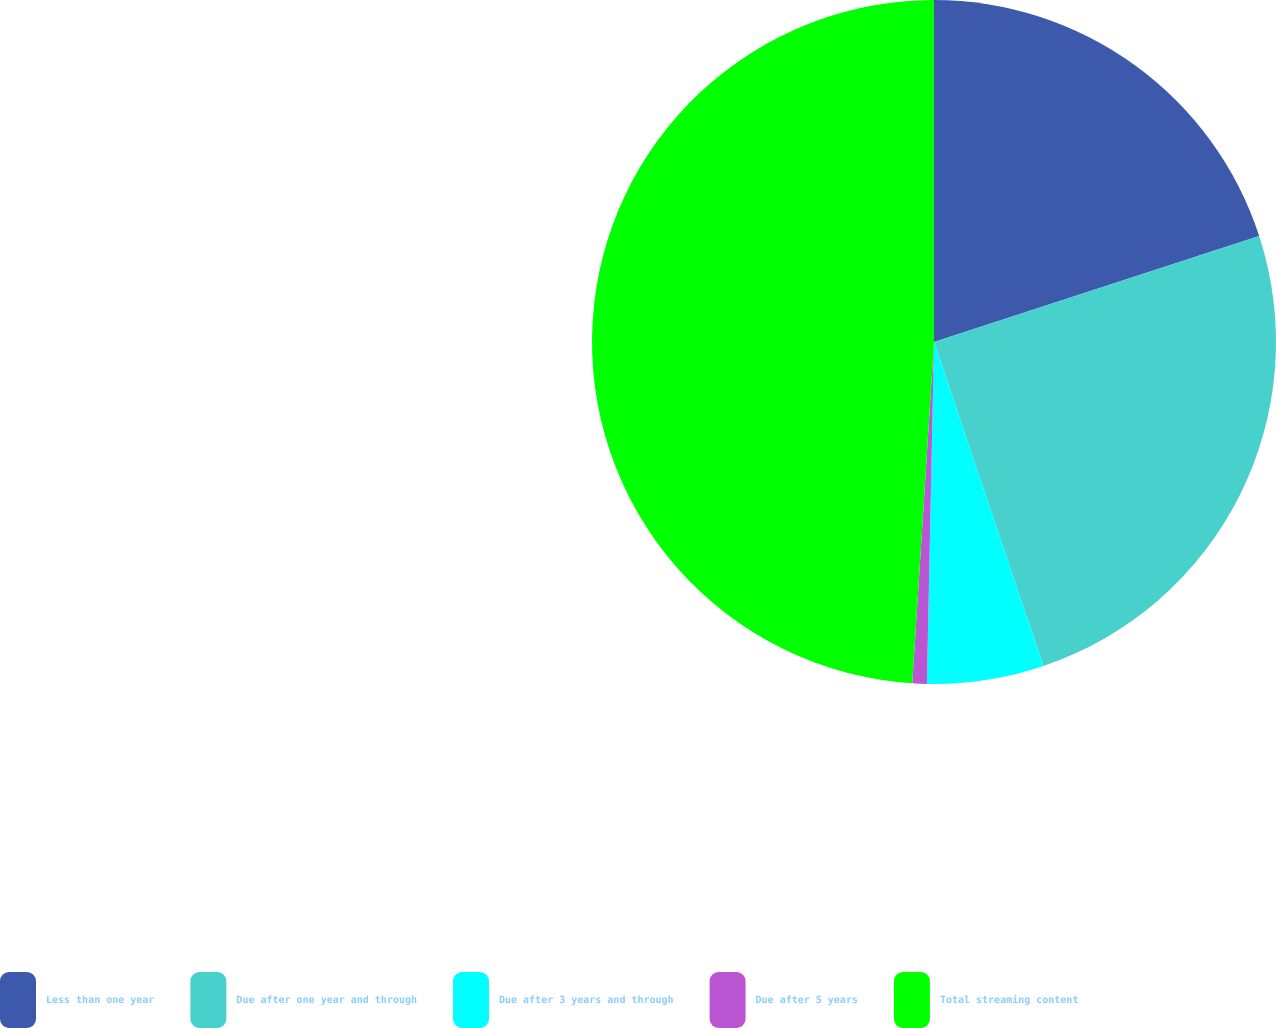<chart> <loc_0><loc_0><loc_500><loc_500><pie_chart><fcel>Less than one year<fcel>Due after one year and through<fcel>Due after 3 years and through<fcel>Due after 5 years<fcel>Total streaming content<nl><fcel>19.99%<fcel>24.83%<fcel>5.51%<fcel>0.68%<fcel>48.99%<nl></chart> 